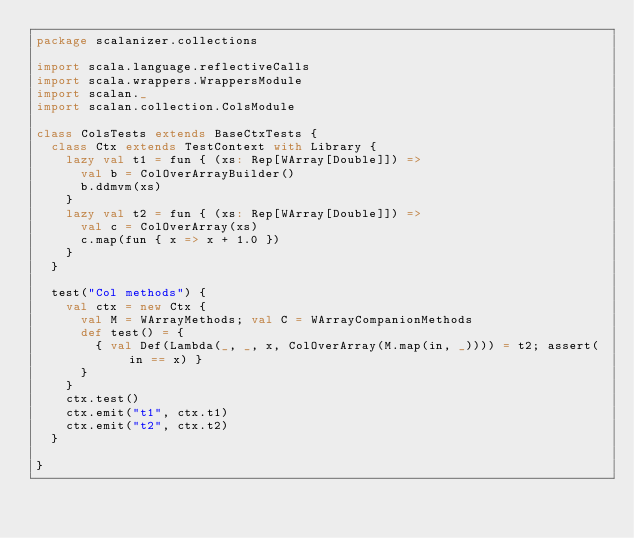Convert code to text. <code><loc_0><loc_0><loc_500><loc_500><_Scala_>package scalanizer.collections

import scala.language.reflectiveCalls
import scala.wrappers.WrappersModule
import scalan._
import scalan.collection.ColsModule

class ColsTests extends BaseCtxTests {
  class Ctx extends TestContext with Library {
    lazy val t1 = fun { (xs: Rep[WArray[Double]]) =>
      val b = ColOverArrayBuilder()
      b.ddmvm(xs)
    }
    lazy val t2 = fun { (xs: Rep[WArray[Double]]) =>
      val c = ColOverArray(xs)
      c.map(fun { x => x + 1.0 })
    }
  }

  test("Col methods") {
    val ctx = new Ctx {
      val M = WArrayMethods; val C = WArrayCompanionMethods
      def test() = {
        { val Def(Lambda(_, _, x, ColOverArray(M.map(in, _)))) = t2; assert(in == x) }
      }
    }
    ctx.test()
    ctx.emit("t1", ctx.t1)
    ctx.emit("t2", ctx.t2)
  }

}
</code> 